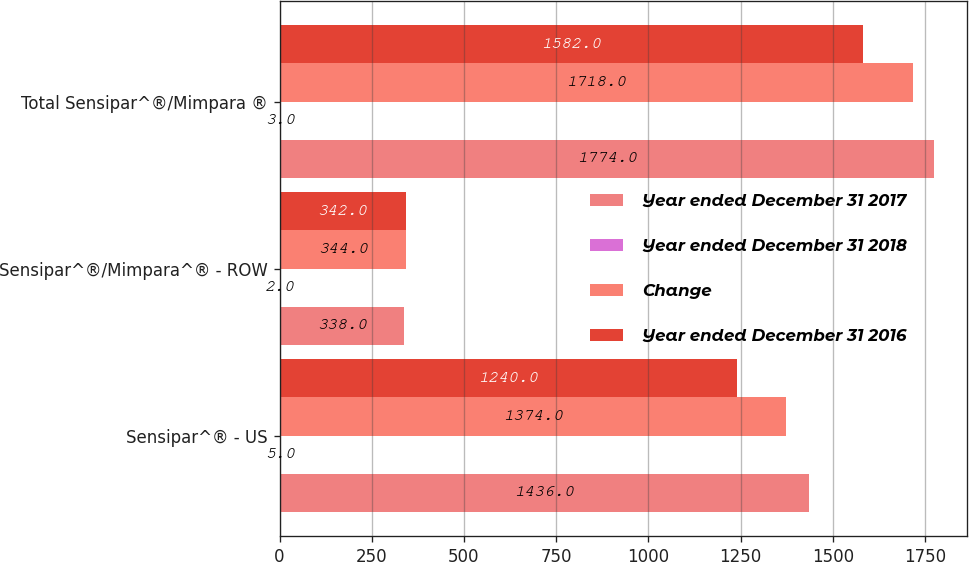Convert chart. <chart><loc_0><loc_0><loc_500><loc_500><stacked_bar_chart><ecel><fcel>Sensipar^® - US<fcel>Sensipar^®/Mimpara^® - ROW<fcel>Total Sensipar^®/Mimpara ®<nl><fcel>Year ended December 31 2017<fcel>1436<fcel>338<fcel>1774<nl><fcel>Year ended December 31 2018<fcel>5<fcel>2<fcel>3<nl><fcel>Change<fcel>1374<fcel>344<fcel>1718<nl><fcel>Year ended December 31 2016<fcel>1240<fcel>342<fcel>1582<nl></chart> 